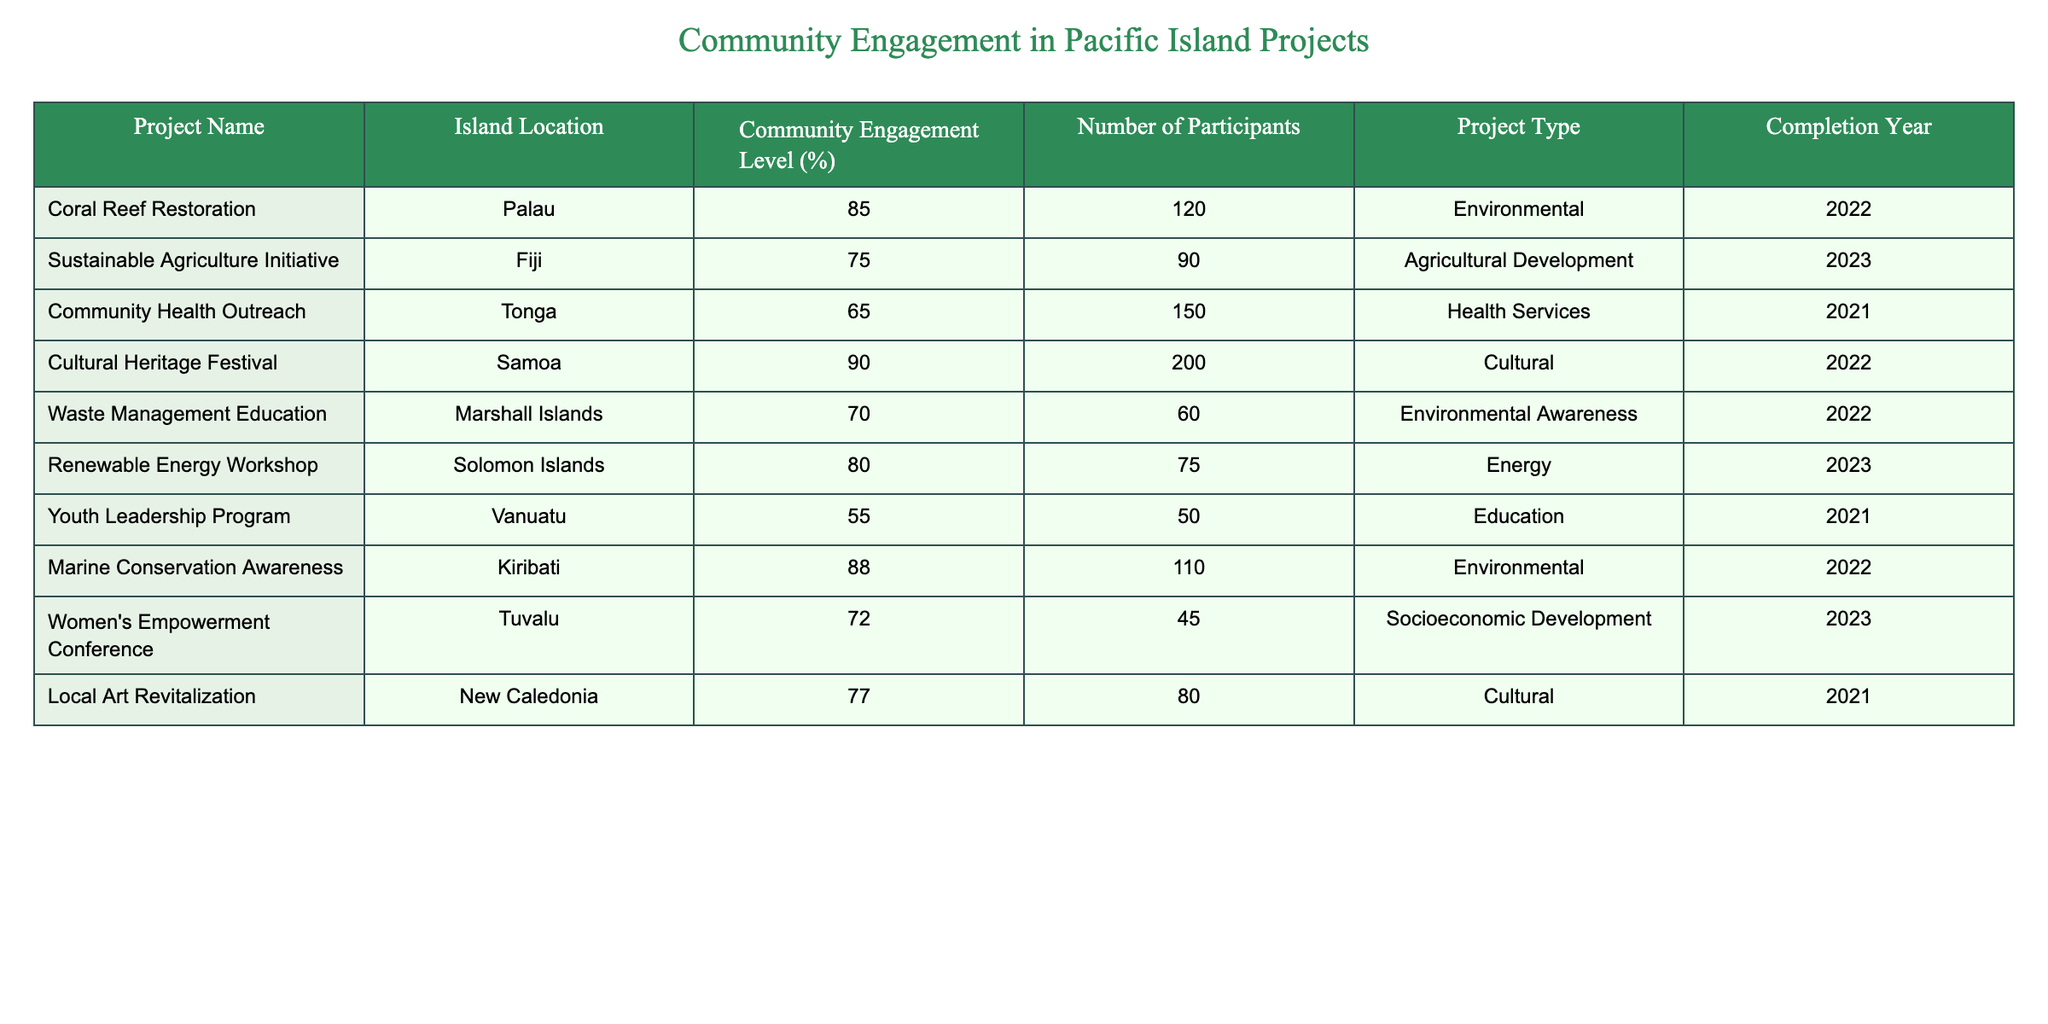What is the community engagement level for the Coral Reef Restoration project? The Coral Reef Restoration project is located in Palau, and the community engagement level is explicitly listed as 85%.
Answer: 85% How many participants were involved in the Cultural Heritage Festival? The Cultural Heritage Festival, which took place in Samoa, has a record of 200 participants, as noted in the table.
Answer: 200 Which project type received the highest level of community engagement? By analyzing the community engagement levels, the Cultural Heritage Festival with a level of 90% ranks the highest among the projects.
Answer: Cultural What is the average number of participants across all projects? To find the average number of participants, sum the participants (120 + 90 + 150 + 200 + 60 + 75 + 50 + 110 + 45 + 80 = 980) and divide by the number of projects (10). Thus, 980/10 = 98.
Answer: 98 Did any project have a community engagement level below 60%? Reviewing the engagement levels shows that the Youth Leadership Program in Vanuatu has a level of 55%, confirming that it is below 60%.
Answer: Yes How does the community engagement level of the Sustainable Agriculture Initiative compare to the Renewable Energy Workshop? The Sustainable Agriculture Initiative has a community engagement level of 75%, while the Renewable Energy Workshop has an engagement level of 80%. Since 75% is less than 80%, the Renewable Energy Workshop has a higher level of engagement.
Answer: Renewable Energy Workshop Which island project had the fewest participants, and what was the engagement level? Scanning the table, the Women's Empowerment Conference in Tuvalu had the fewest participants at 45, with a community engagement level of 72%.
Answer: 45 participants, 72% engagement What is the total community engagement level for all environmental projects? The table contains three environmental projects: Coral Reef Restoration (85%), Waste Management Education (70%), and Marine Conservation Awareness (88%). Summing these engagement levels gives 85 + 70 + 88 = 243%. The total engagement level for environmental projects is 243%.
Answer: 243% Is the Community Health Outreach project in Tonga more or less engaging than the Women's Empowerment Conference in Tuvalu? The Community Health Outreach project has a community engagement level of 65%, while the Women's Empowerment Conference has an engagement level of 72%. Since 65% is less than 72%, the Community Health Outreach project is less engaging.
Answer: Less engaging 